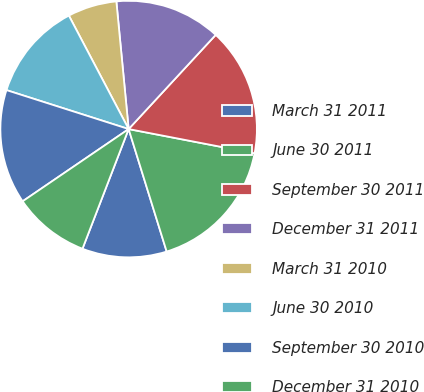Convert chart. <chart><loc_0><loc_0><loc_500><loc_500><pie_chart><fcel>March 31 2011<fcel>June 30 2011<fcel>September 30 2011<fcel>December 31 2011<fcel>March 31 2010<fcel>June 30 2010<fcel>September 30 2010<fcel>December 31 2010<nl><fcel>10.65%<fcel>17.18%<fcel>16.15%<fcel>13.4%<fcel>6.19%<fcel>12.37%<fcel>14.43%<fcel>9.62%<nl></chart> 